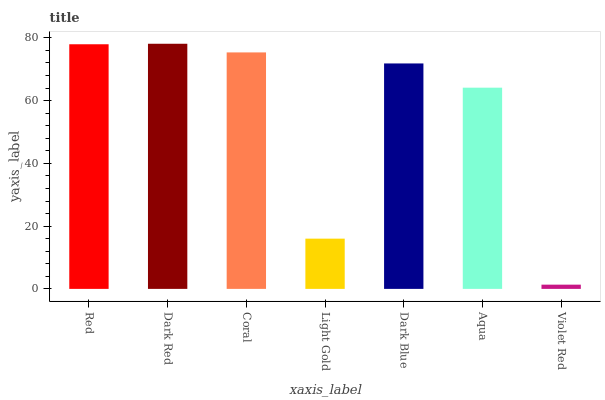Is Violet Red the minimum?
Answer yes or no. Yes. Is Dark Red the maximum?
Answer yes or no. Yes. Is Coral the minimum?
Answer yes or no. No. Is Coral the maximum?
Answer yes or no. No. Is Dark Red greater than Coral?
Answer yes or no. Yes. Is Coral less than Dark Red?
Answer yes or no. Yes. Is Coral greater than Dark Red?
Answer yes or no. No. Is Dark Red less than Coral?
Answer yes or no. No. Is Dark Blue the high median?
Answer yes or no. Yes. Is Dark Blue the low median?
Answer yes or no. Yes. Is Red the high median?
Answer yes or no. No. Is Red the low median?
Answer yes or no. No. 